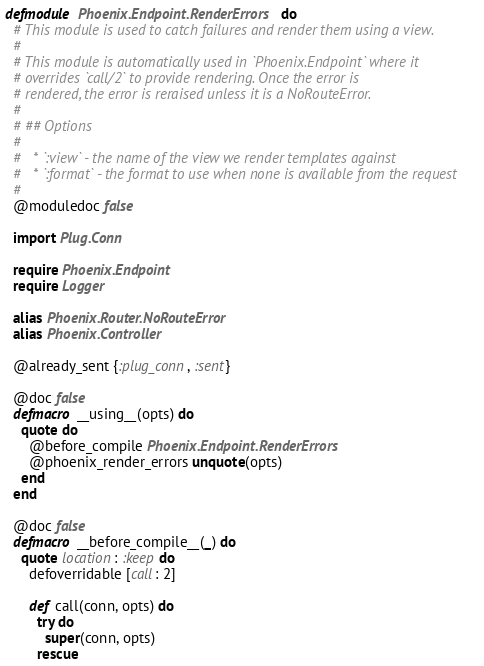Convert code to text. <code><loc_0><loc_0><loc_500><loc_500><_Elixir_>defmodule Phoenix.Endpoint.RenderErrors do
  # This module is used to catch failures and render them using a view.
  #
  # This module is automatically used in `Phoenix.Endpoint` where it
  # overrides `call/2` to provide rendering. Once the error is
  # rendered, the error is reraised unless it is a NoRouteError.
  #
  # ## Options
  #
  #   * `:view` - the name of the view we render templates against
  #   * `:format` - the format to use when none is available from the request
  #
  @moduledoc false

  import Plug.Conn

  require Phoenix.Endpoint
  require Logger

  alias Phoenix.Router.NoRouteError
  alias Phoenix.Controller

  @already_sent {:plug_conn, :sent}

  @doc false
  defmacro __using__(opts) do
    quote do
      @before_compile Phoenix.Endpoint.RenderErrors
      @phoenix_render_errors unquote(opts)
    end
  end

  @doc false
  defmacro __before_compile__(_) do
    quote location: :keep do
      defoverridable [call: 2]

      def call(conn, opts) do
        try do
          super(conn, opts)
        rescue</code> 